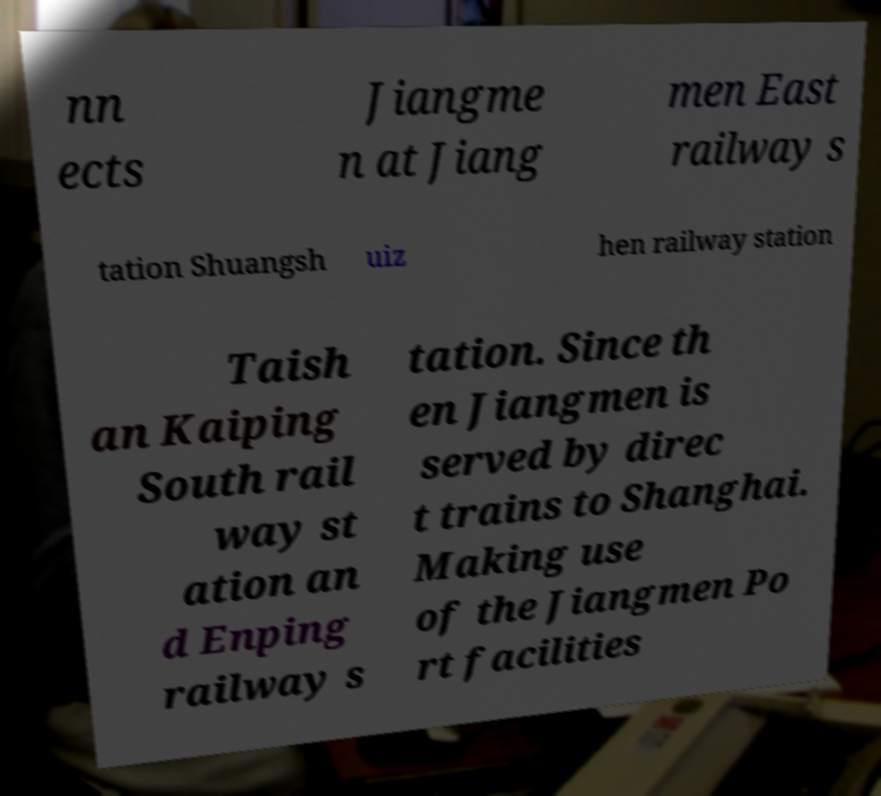Could you extract and type out the text from this image? nn ects Jiangme n at Jiang men East railway s tation Shuangsh uiz hen railway station Taish an Kaiping South rail way st ation an d Enping railway s tation. Since th en Jiangmen is served by direc t trains to Shanghai. Making use of the Jiangmen Po rt facilities 